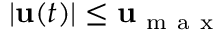Convert formula to latex. <formula><loc_0><loc_0><loc_500><loc_500>\begin{array} { r } { | u ( t ) | \leq u _ { m a x } } \end{array}</formula> 